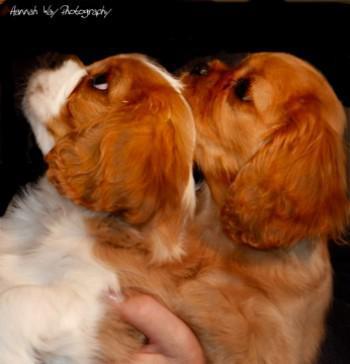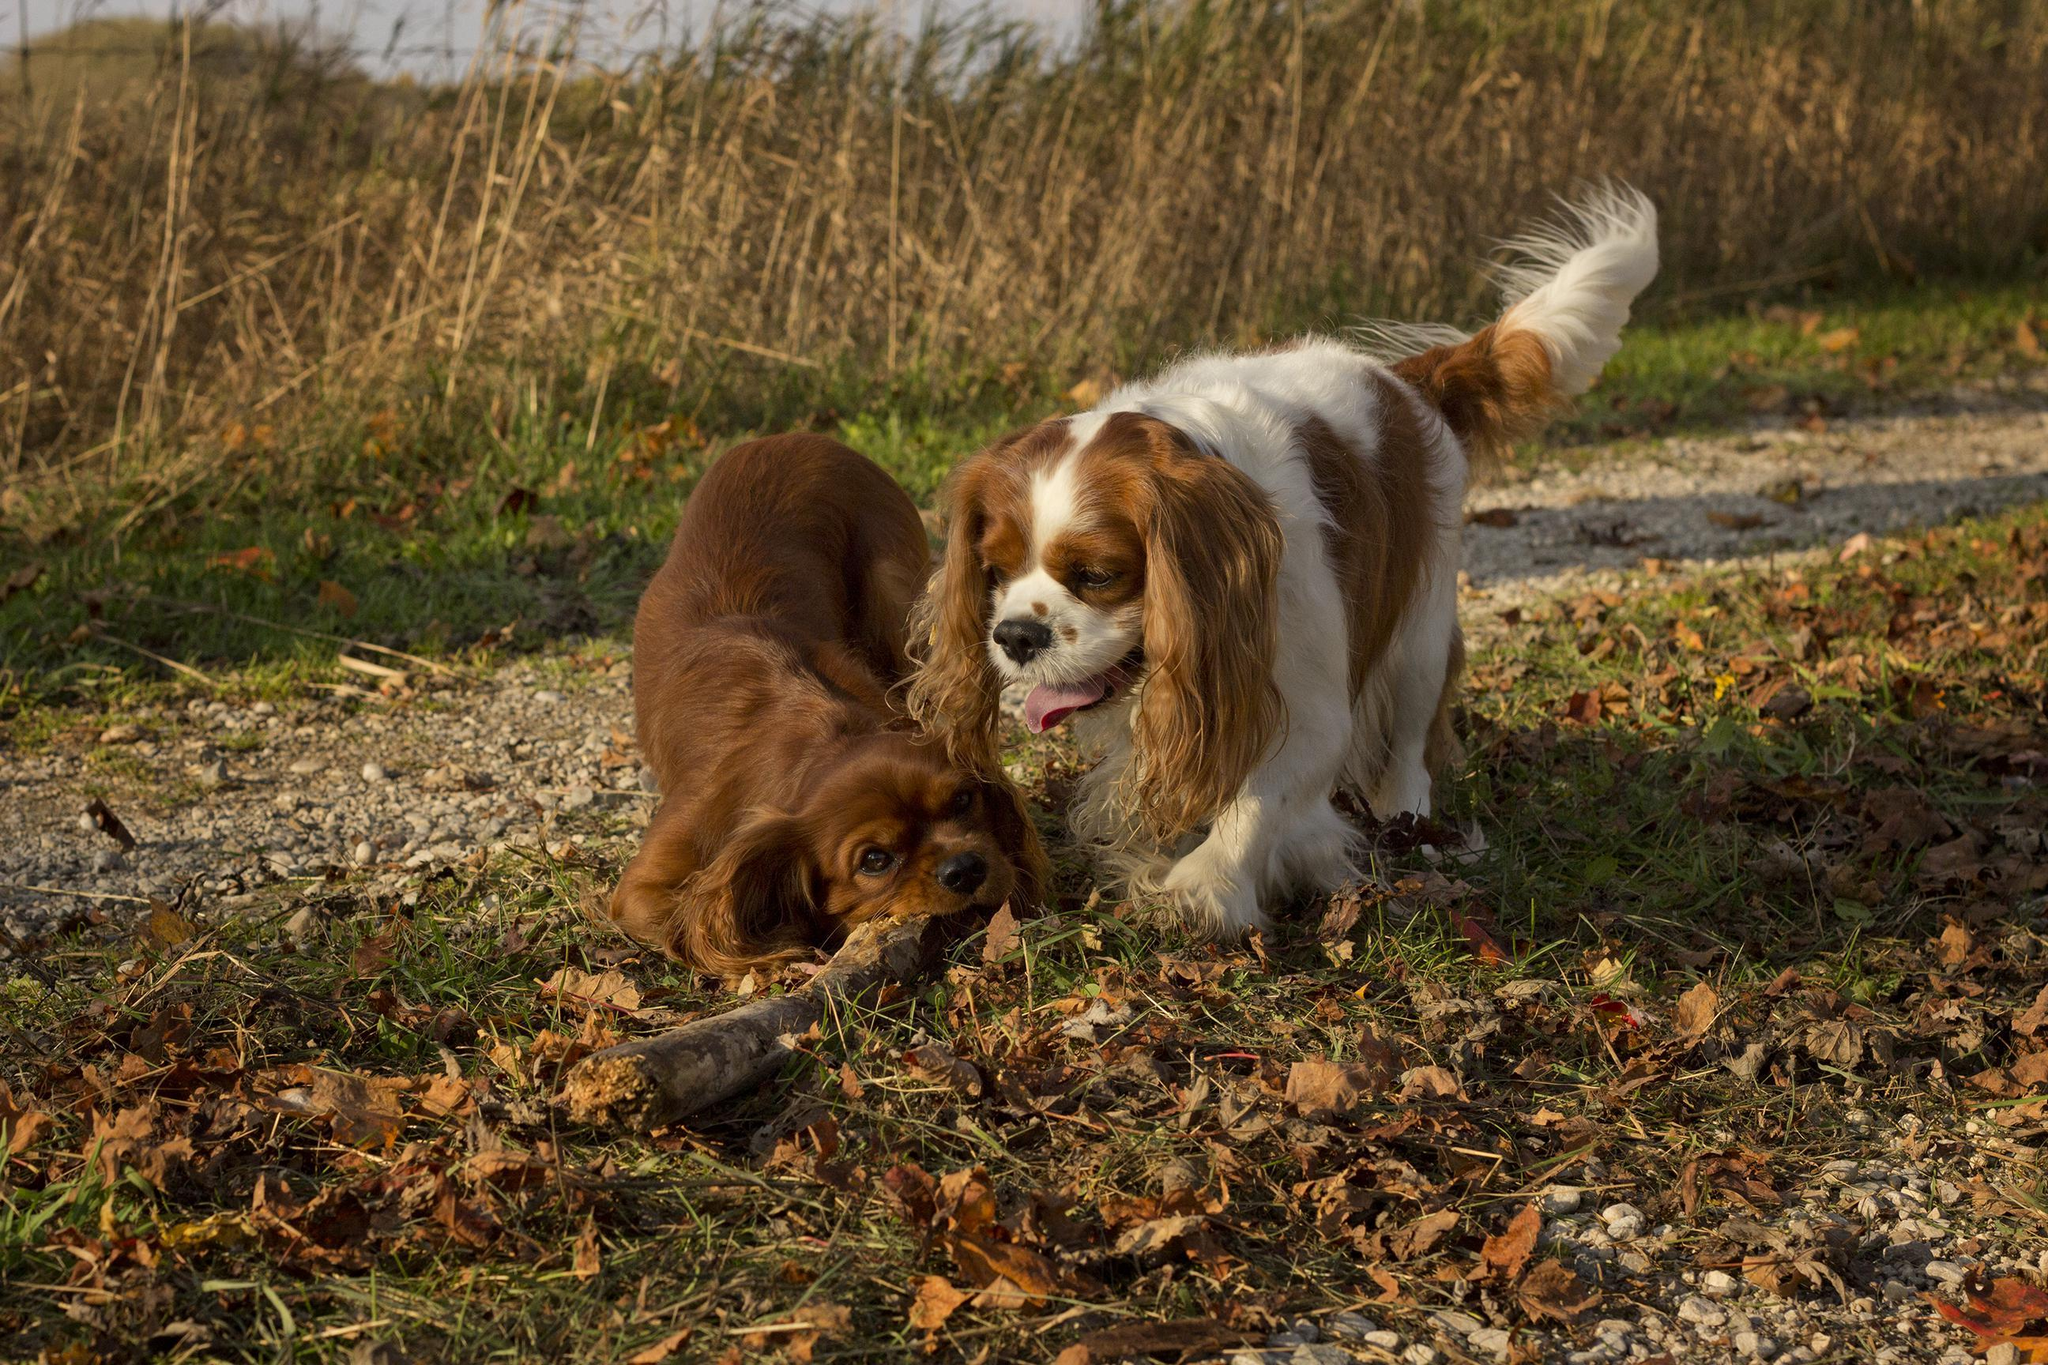The first image is the image on the left, the second image is the image on the right. For the images displayed, is the sentence "Two puppies are being held by human hands." factually correct? Answer yes or no. Yes. 